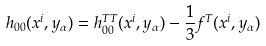<formula> <loc_0><loc_0><loc_500><loc_500>h _ { 0 0 } ( x ^ { i } , y _ { \alpha } ) = h _ { 0 0 } ^ { T T } ( x ^ { i } , y _ { \alpha } ) - \frac { 1 } { 3 } f ^ { T } ( x ^ { i } , y _ { \alpha } )</formula> 